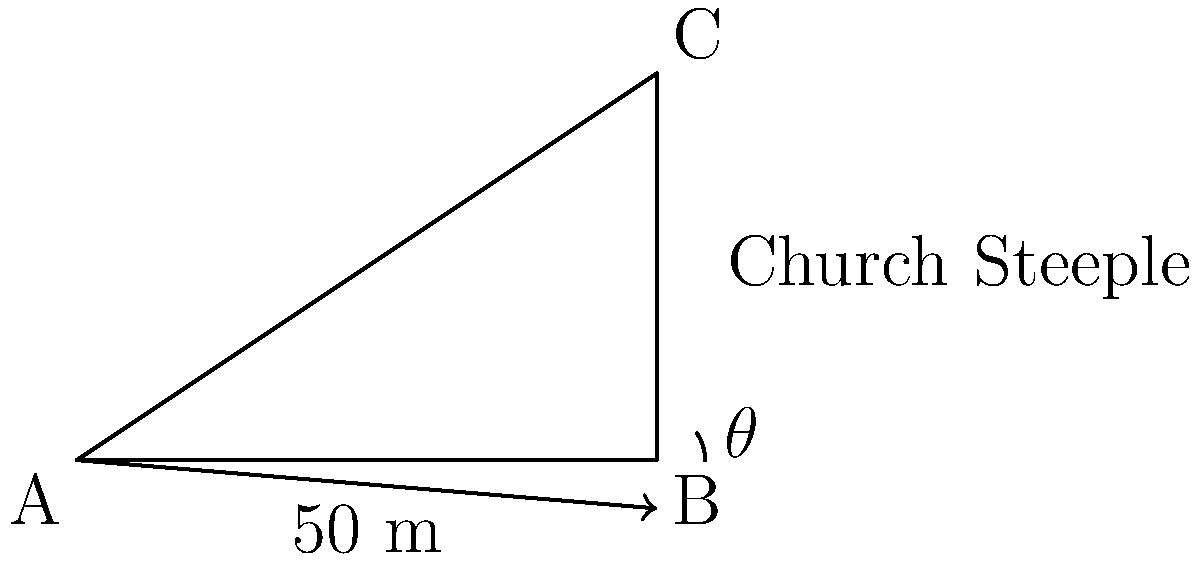You're visiting a traditional Polish church in your ancestral hometown. Standing 50 meters away from the base of the church, you observe the steeple at an angle of elevation of 33.69°. Calculate the height of the church steeple. Let's approach this step-by-step using trigonometry:

1) We can model this scenario as a right triangle, where:
   - The base of the triangle is the distance from the observer to the church (50 m)
   - The height of the triangle is the height of the steeple (what we're solving for)
   - The angle of elevation is the angle between the base and the line of sight (33.69°)

2) In this right triangle, we know:
   - The adjacent side (base) = 50 m
   - The angle = 33.69°
   - We need to find the opposite side (height)

3) This scenario calls for the tangent function, which is defined as:

   $\tan \theta = \frac{\text{opposite}}{\text{adjacent}}$

4) Substituting our known values:

   $\tan 33.69° = \frac{\text{height}}{50}$

5) To solve for height, we multiply both sides by 50:

   $50 \cdot \tan 33.69° = \text{height}$

6) Using a calculator (or trigonometric tables):

   $\text{height} = 50 \cdot \tan 33.69° \approx 33.33$ meters

Therefore, the height of the church steeple is approximately 33.33 meters.
Answer: 33.33 m 